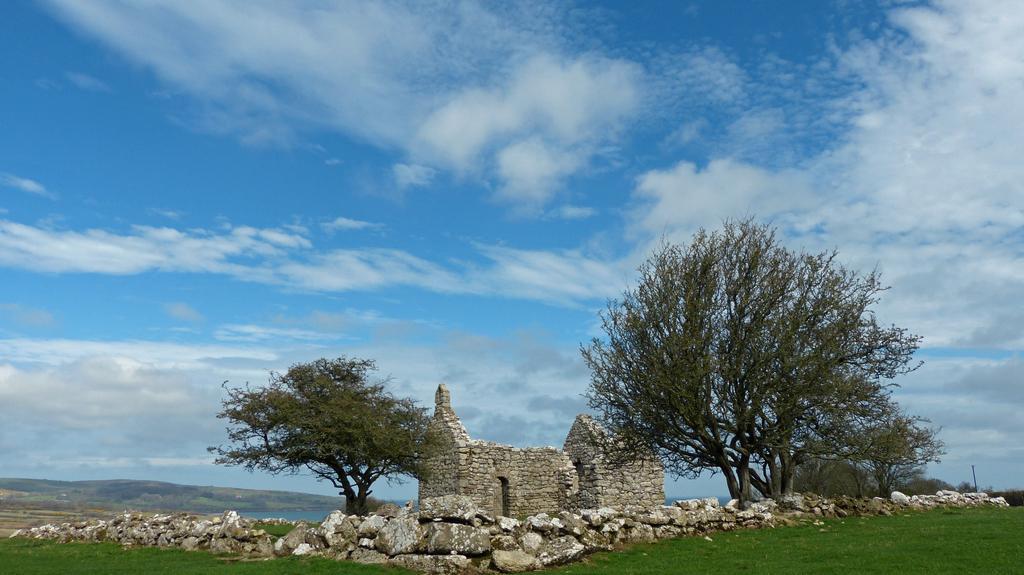Describe this image in one or two sentences. In this image I can see some grass on the ground, a wall which is made up of rocks, few trees and a building which is made of rocks. In the background I can see the water and the sky. 